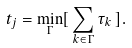<formula> <loc_0><loc_0><loc_500><loc_500>t _ { j } = \min _ { \Gamma } [ \, \sum _ { k \in \Gamma } \tau _ { k } \, ] .</formula> 